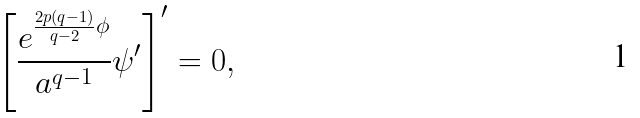Convert formula to latex. <formula><loc_0><loc_0><loc_500><loc_500>\left [ \frac { e ^ { \frac { 2 p ( q - 1 ) } { q - 2 } \phi } } { a ^ { q - 1 } } \psi ^ { \prime } \right ] ^ { \prime } = 0 ,</formula> 